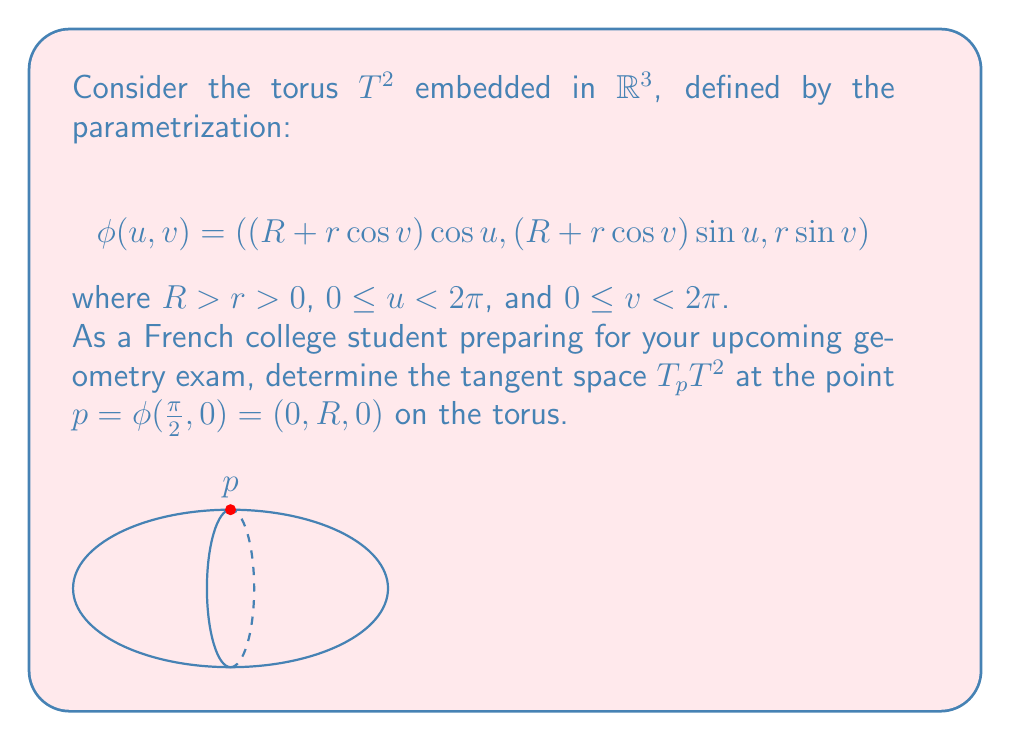What is the answer to this math problem? Let's approach this step-by-step:

1) The tangent space at a point on a manifold is spanned by the partial derivatives of the parametrization at that point.

2) We need to calculate $\frac{\partial \phi}{\partial u}$ and $\frac{\partial \phi}{\partial v}$ at $u = \frac{\pi}{2}$ and $v = 0$.

3) First, let's calculate $\frac{\partial \phi}{\partial u}$:

   $$\frac{\partial \phi}{\partial u} = (-(R + r\cos v)\sin u, (R + r\cos v)\cos u, 0)$$

4) At $u = \frac{\pi}{2}$ and $v = 0$:

   $$\frac{\partial \phi}{\partial u}|_{(\frac{\pi}{2}, 0)} = (-R, 0, 0)$$

5) Now, let's calculate $\frac{\partial \phi}{\partial v}$:

   $$\frac{\partial \phi}{\partial v} = (-r\sin v \cos u, -r\sin v \sin u, r\cos v)$$

6) At $u = \frac{\pi}{2}$ and $v = 0$:

   $$\frac{\partial \phi}{\partial v}|_{(\frac{\pi}{2}, 0)} = (0, 0, r)$$

7) The tangent space $T_pT^2$ is the span of these two vectors:

   $$T_pT^2 = \text{span}\{(-R, 0, 0), (0, 0, r)\}$$

8) This represents a plane in $\mathbb{R}^3$ passing through the point $p = (0, R, 0)$.
Answer: $T_pT^2 = \text{span}\{(-R, 0, 0), (0, 0, r)\}$ 